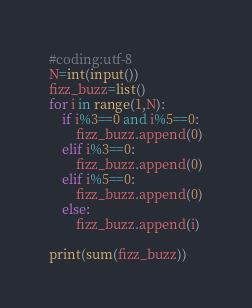<code> <loc_0><loc_0><loc_500><loc_500><_Python_>#coding:utf-8
N=int(input())
fizz_buzz=list()
for i in range(1,N):
	if i%3==0 and i%5==0:
		fizz_buzz.append(0)
	elif i%3==0:
		fizz_buzz.append(0)
	elif i%5==0:
		fizz_buzz.append(0)
	else:
		fizz_buzz.append(i)

print(sum(fizz_buzz))</code> 